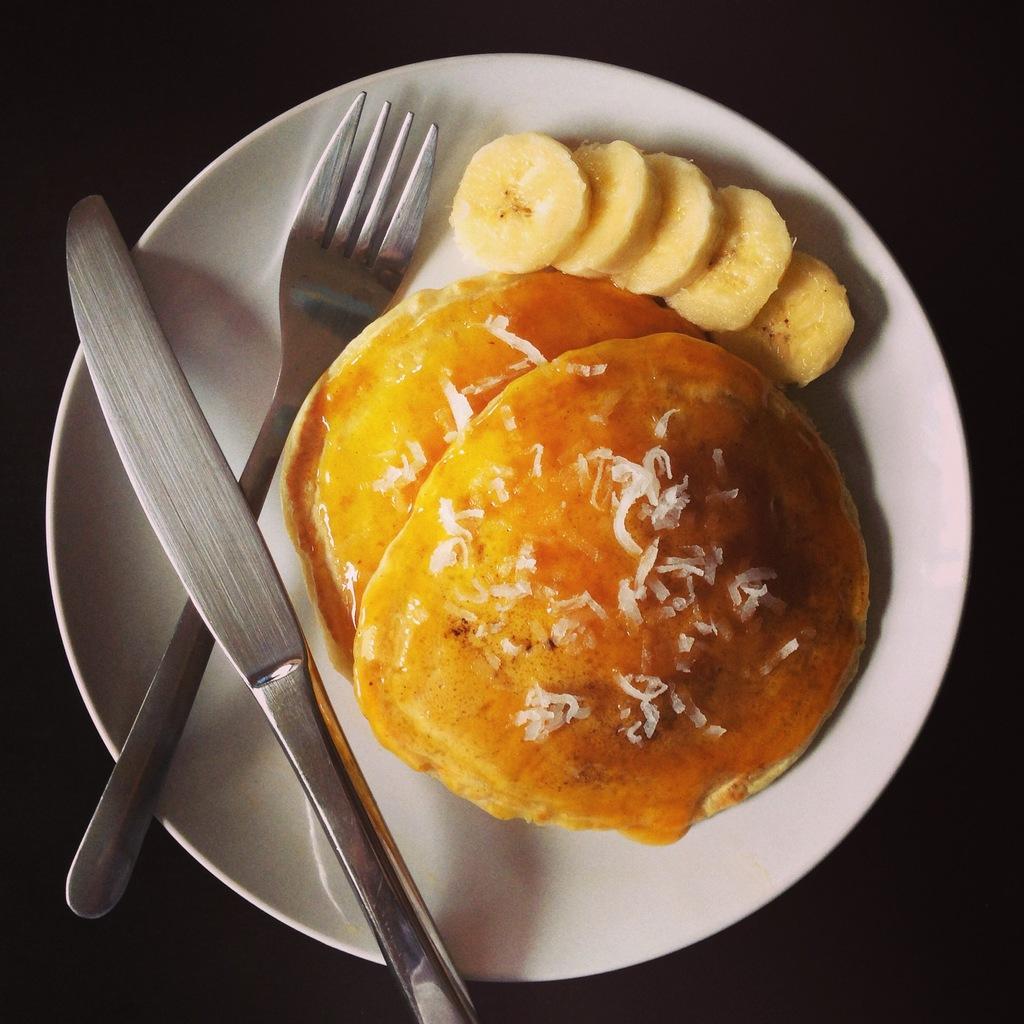Please provide a concise description of this image. In this picture there are pancakes and there are banana slices and there is a fork and there is a knife on the white plate. At the bottom there is a black background. 